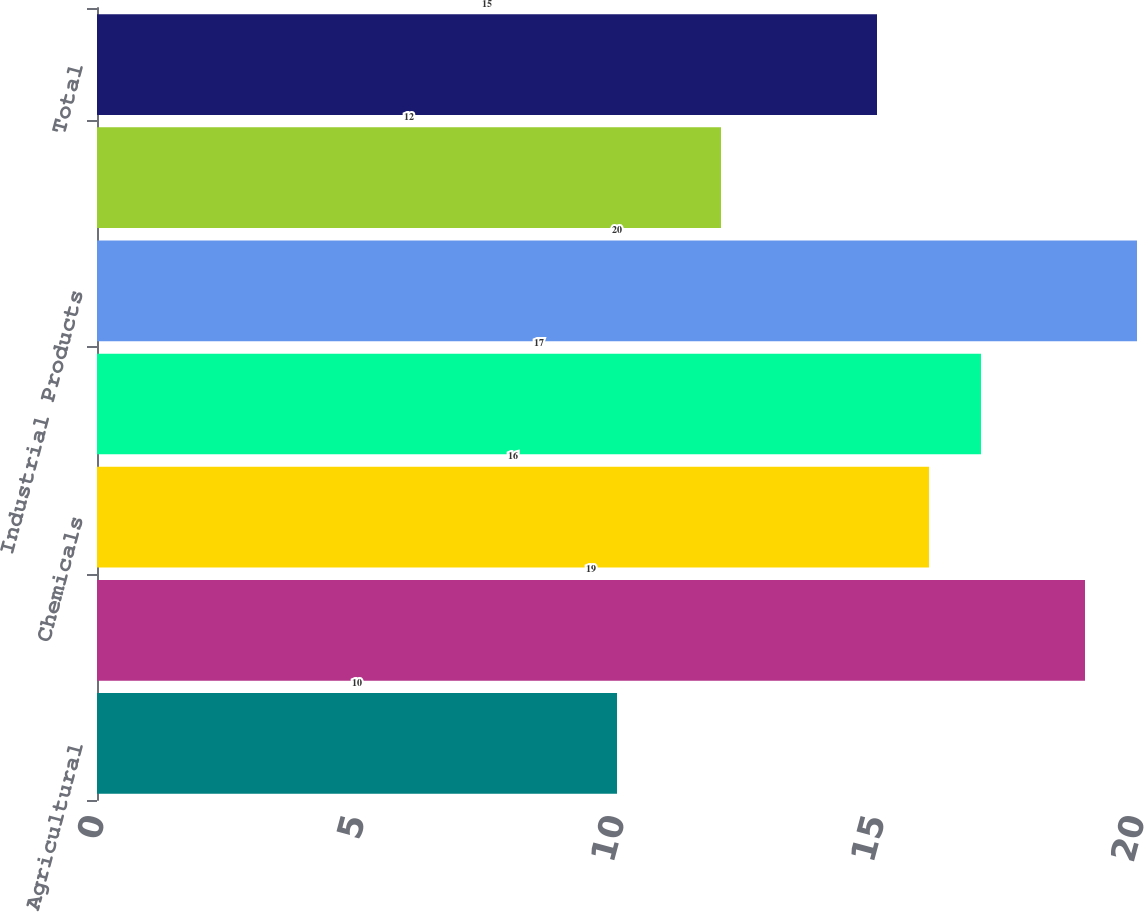Convert chart to OTSL. <chart><loc_0><loc_0><loc_500><loc_500><bar_chart><fcel>Agricultural<fcel>Automotive<fcel>Chemicals<fcel>Energy<fcel>Industrial Products<fcel>Intermodal<fcel>Total<nl><fcel>10<fcel>19<fcel>16<fcel>17<fcel>20<fcel>12<fcel>15<nl></chart> 